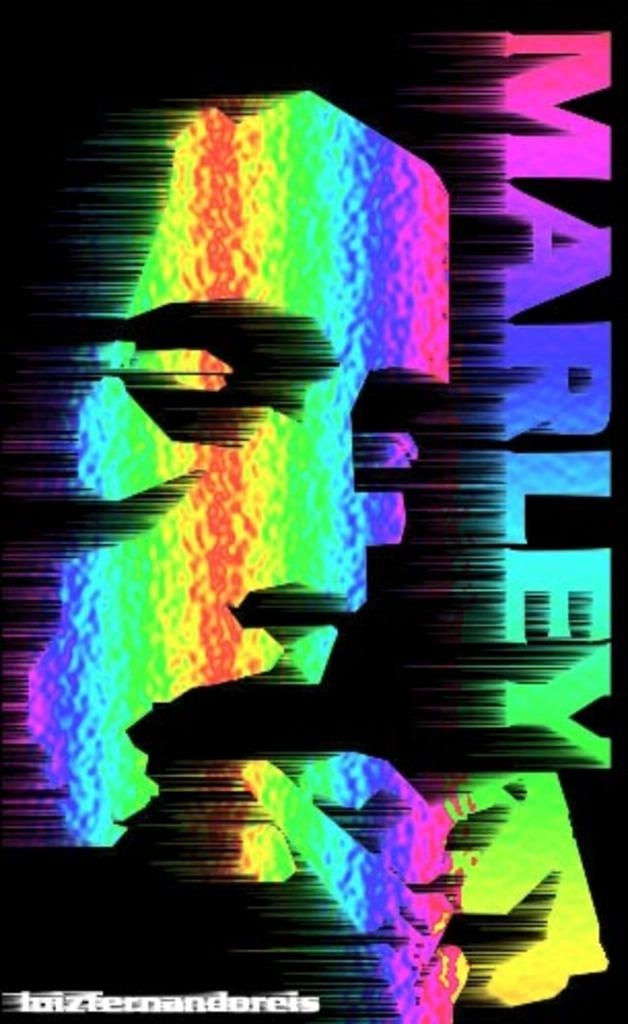<image>
Offer a succinct explanation of the picture presented. A rainbow colored Marley poster with black background. 